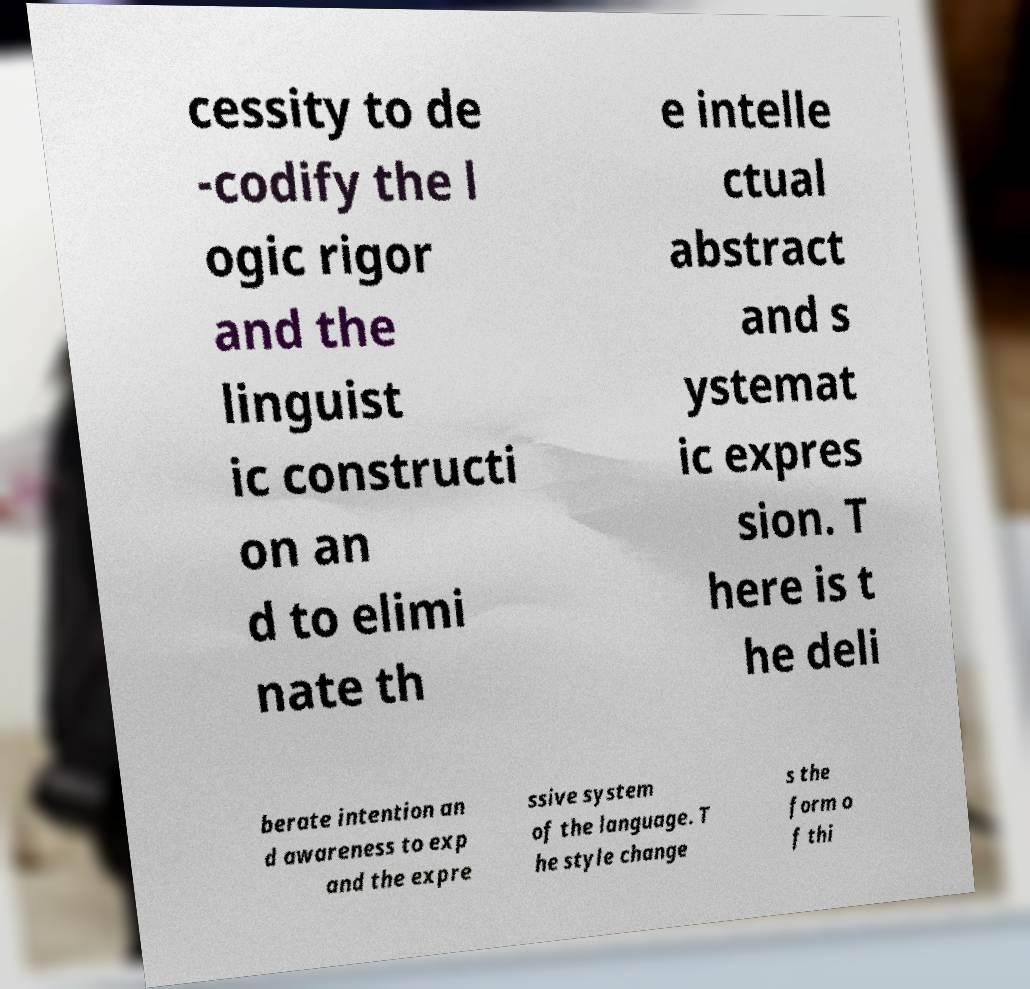For documentation purposes, I need the text within this image transcribed. Could you provide that? cessity to de -codify the l ogic rigor and the linguist ic constructi on an d to elimi nate th e intelle ctual abstract and s ystemat ic expres sion. T here is t he deli berate intention an d awareness to exp and the expre ssive system of the language. T he style change s the form o f thi 